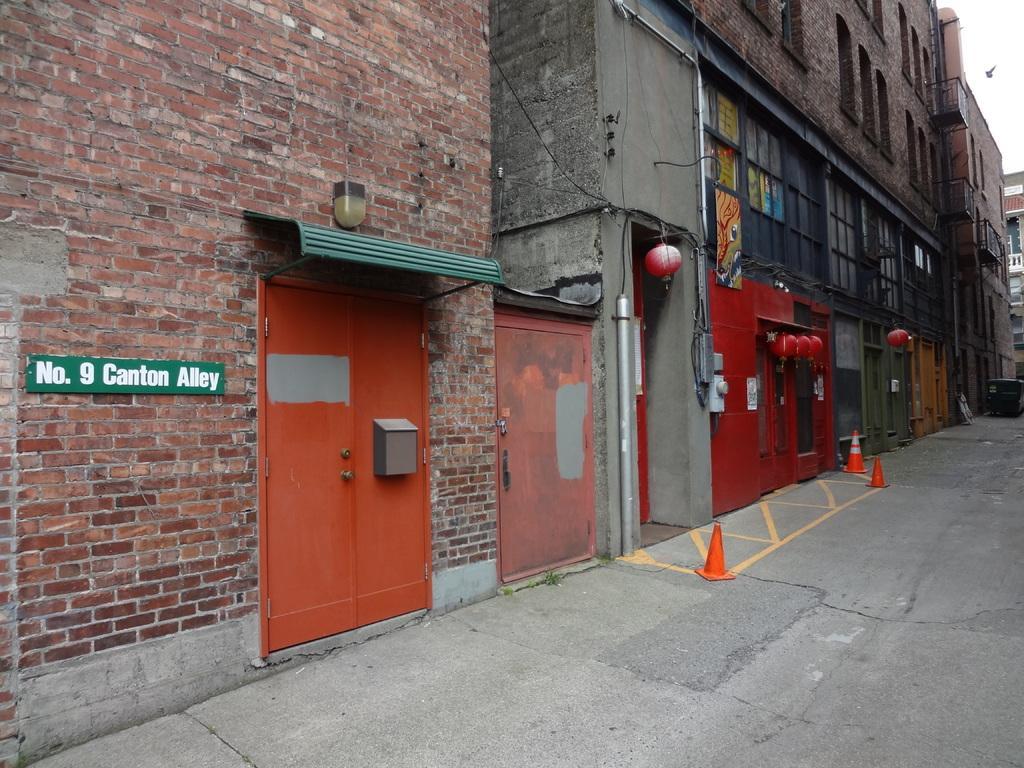Describe this image in one or two sentences. In this image we can see the buildings, safety cones, road, light, board and also the sky. 